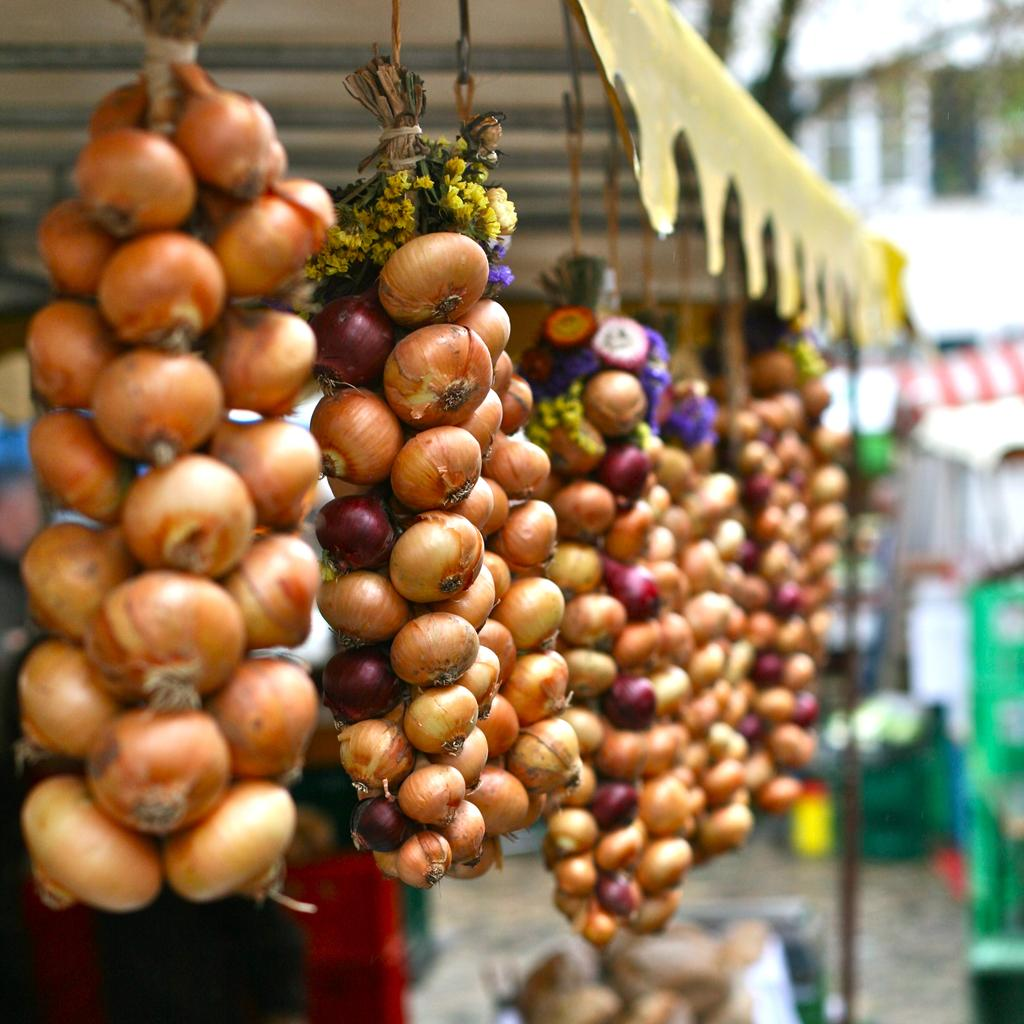What type of vegetable is visible in the image? There is a bunch of onions in the image. What structure can be seen in the image? There is a pole in the image. What material is present in the image? There are threads in the image. What type of shelter is in the image? There is a tent in the image. Can you describe the background of the image? The background of the image contains some objects, but they are blurry. What type of sock is hanging on the pole in the image? There is no sock present in the image; it only features a bunch of onions, a pole, threads, a tent, and a blurry background. 